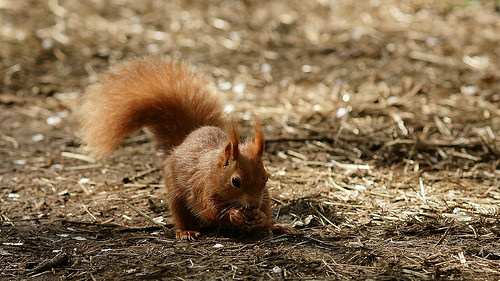<image>
Can you confirm if the nut is in the squirrel? Yes. The nut is contained within or inside the squirrel, showing a containment relationship. 